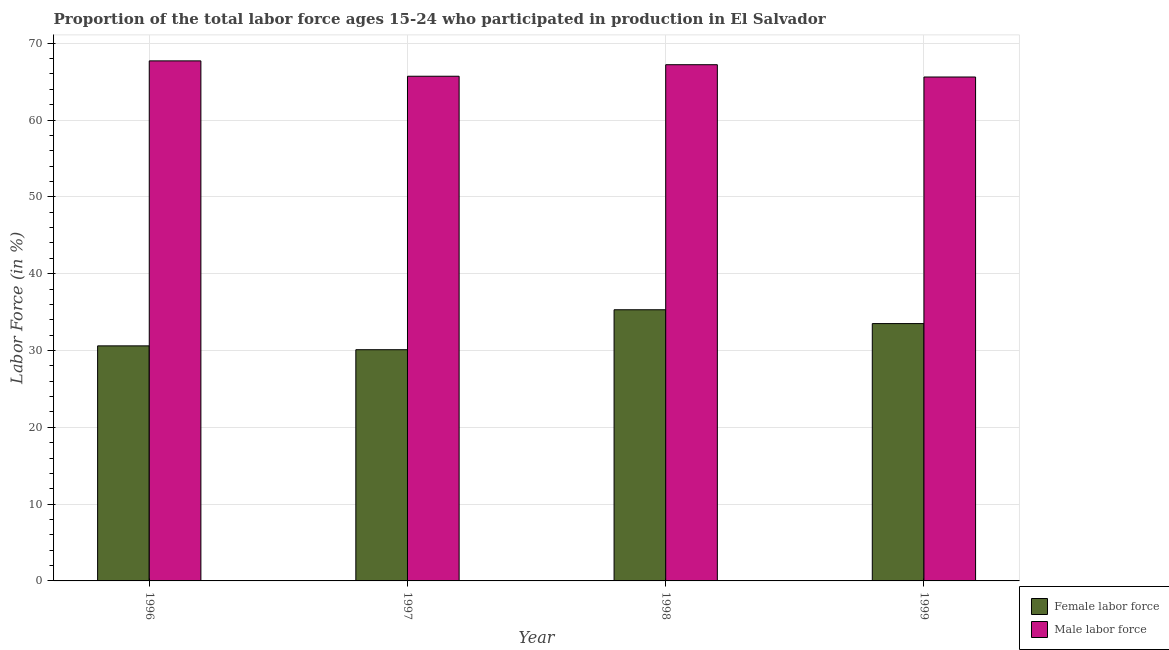How many different coloured bars are there?
Your answer should be compact. 2. How many groups of bars are there?
Ensure brevity in your answer.  4. Are the number of bars on each tick of the X-axis equal?
Provide a short and direct response. Yes. What is the label of the 4th group of bars from the left?
Ensure brevity in your answer.  1999. What is the percentage of male labour force in 1998?
Provide a succinct answer. 67.2. Across all years, what is the maximum percentage of male labour force?
Provide a short and direct response. 67.7. Across all years, what is the minimum percentage of female labor force?
Ensure brevity in your answer.  30.1. In which year was the percentage of female labor force minimum?
Give a very brief answer. 1997. What is the total percentage of female labor force in the graph?
Make the answer very short. 129.5. What is the difference between the percentage of female labor force in 1996 and that in 1998?
Offer a very short reply. -4.7. What is the difference between the percentage of female labor force in 1997 and the percentage of male labour force in 1999?
Your response must be concise. -3.4. What is the average percentage of female labor force per year?
Offer a terse response. 32.37. What is the ratio of the percentage of female labor force in 1996 to that in 1999?
Offer a very short reply. 0.91. Is the percentage of female labor force in 1997 less than that in 1999?
Provide a short and direct response. Yes. What is the difference between the highest and the lowest percentage of male labour force?
Make the answer very short. 2.1. In how many years, is the percentage of female labor force greater than the average percentage of female labor force taken over all years?
Your answer should be very brief. 2. What does the 2nd bar from the left in 1998 represents?
Your response must be concise. Male labor force. What does the 2nd bar from the right in 1998 represents?
Give a very brief answer. Female labor force. How many years are there in the graph?
Your answer should be compact. 4. Does the graph contain any zero values?
Give a very brief answer. No. Does the graph contain grids?
Give a very brief answer. Yes. How are the legend labels stacked?
Offer a very short reply. Vertical. What is the title of the graph?
Your response must be concise. Proportion of the total labor force ages 15-24 who participated in production in El Salvador. What is the label or title of the X-axis?
Provide a succinct answer. Year. What is the label or title of the Y-axis?
Provide a succinct answer. Labor Force (in %). What is the Labor Force (in %) of Female labor force in 1996?
Offer a terse response. 30.6. What is the Labor Force (in %) in Male labor force in 1996?
Offer a very short reply. 67.7. What is the Labor Force (in %) in Female labor force in 1997?
Offer a very short reply. 30.1. What is the Labor Force (in %) of Male labor force in 1997?
Give a very brief answer. 65.7. What is the Labor Force (in %) of Female labor force in 1998?
Give a very brief answer. 35.3. What is the Labor Force (in %) in Male labor force in 1998?
Your answer should be very brief. 67.2. What is the Labor Force (in %) in Female labor force in 1999?
Keep it short and to the point. 33.5. What is the Labor Force (in %) in Male labor force in 1999?
Ensure brevity in your answer.  65.6. Across all years, what is the maximum Labor Force (in %) in Female labor force?
Offer a terse response. 35.3. Across all years, what is the maximum Labor Force (in %) in Male labor force?
Keep it short and to the point. 67.7. Across all years, what is the minimum Labor Force (in %) in Female labor force?
Provide a succinct answer. 30.1. Across all years, what is the minimum Labor Force (in %) in Male labor force?
Your answer should be compact. 65.6. What is the total Labor Force (in %) in Female labor force in the graph?
Your answer should be very brief. 129.5. What is the total Labor Force (in %) of Male labor force in the graph?
Your response must be concise. 266.2. What is the difference between the Labor Force (in %) in Female labor force in 1996 and that in 1999?
Provide a short and direct response. -2.9. What is the difference between the Labor Force (in %) of Female labor force in 1997 and that in 1998?
Give a very brief answer. -5.2. What is the difference between the Labor Force (in %) of Female labor force in 1998 and that in 1999?
Make the answer very short. 1.8. What is the difference between the Labor Force (in %) in Male labor force in 1998 and that in 1999?
Provide a short and direct response. 1.6. What is the difference between the Labor Force (in %) of Female labor force in 1996 and the Labor Force (in %) of Male labor force in 1997?
Ensure brevity in your answer.  -35.1. What is the difference between the Labor Force (in %) in Female labor force in 1996 and the Labor Force (in %) in Male labor force in 1998?
Your answer should be very brief. -36.6. What is the difference between the Labor Force (in %) of Female labor force in 1996 and the Labor Force (in %) of Male labor force in 1999?
Provide a succinct answer. -35. What is the difference between the Labor Force (in %) in Female labor force in 1997 and the Labor Force (in %) in Male labor force in 1998?
Offer a terse response. -37.1. What is the difference between the Labor Force (in %) of Female labor force in 1997 and the Labor Force (in %) of Male labor force in 1999?
Offer a very short reply. -35.5. What is the difference between the Labor Force (in %) in Female labor force in 1998 and the Labor Force (in %) in Male labor force in 1999?
Give a very brief answer. -30.3. What is the average Labor Force (in %) of Female labor force per year?
Your response must be concise. 32.38. What is the average Labor Force (in %) in Male labor force per year?
Make the answer very short. 66.55. In the year 1996, what is the difference between the Labor Force (in %) in Female labor force and Labor Force (in %) in Male labor force?
Your answer should be very brief. -37.1. In the year 1997, what is the difference between the Labor Force (in %) in Female labor force and Labor Force (in %) in Male labor force?
Your answer should be very brief. -35.6. In the year 1998, what is the difference between the Labor Force (in %) in Female labor force and Labor Force (in %) in Male labor force?
Offer a terse response. -31.9. In the year 1999, what is the difference between the Labor Force (in %) of Female labor force and Labor Force (in %) of Male labor force?
Ensure brevity in your answer.  -32.1. What is the ratio of the Labor Force (in %) in Female labor force in 1996 to that in 1997?
Provide a short and direct response. 1.02. What is the ratio of the Labor Force (in %) in Male labor force in 1996 to that in 1997?
Give a very brief answer. 1.03. What is the ratio of the Labor Force (in %) in Female labor force in 1996 to that in 1998?
Provide a succinct answer. 0.87. What is the ratio of the Labor Force (in %) in Male labor force in 1996 to that in 1998?
Offer a very short reply. 1.01. What is the ratio of the Labor Force (in %) of Female labor force in 1996 to that in 1999?
Offer a very short reply. 0.91. What is the ratio of the Labor Force (in %) in Male labor force in 1996 to that in 1999?
Give a very brief answer. 1.03. What is the ratio of the Labor Force (in %) in Female labor force in 1997 to that in 1998?
Your answer should be compact. 0.85. What is the ratio of the Labor Force (in %) of Male labor force in 1997 to that in 1998?
Your answer should be very brief. 0.98. What is the ratio of the Labor Force (in %) in Female labor force in 1997 to that in 1999?
Make the answer very short. 0.9. What is the ratio of the Labor Force (in %) of Male labor force in 1997 to that in 1999?
Your answer should be very brief. 1. What is the ratio of the Labor Force (in %) of Female labor force in 1998 to that in 1999?
Ensure brevity in your answer.  1.05. What is the ratio of the Labor Force (in %) of Male labor force in 1998 to that in 1999?
Make the answer very short. 1.02. What is the difference between the highest and the second highest Labor Force (in %) in Female labor force?
Your response must be concise. 1.8. What is the difference between the highest and the lowest Labor Force (in %) of Male labor force?
Provide a succinct answer. 2.1. 